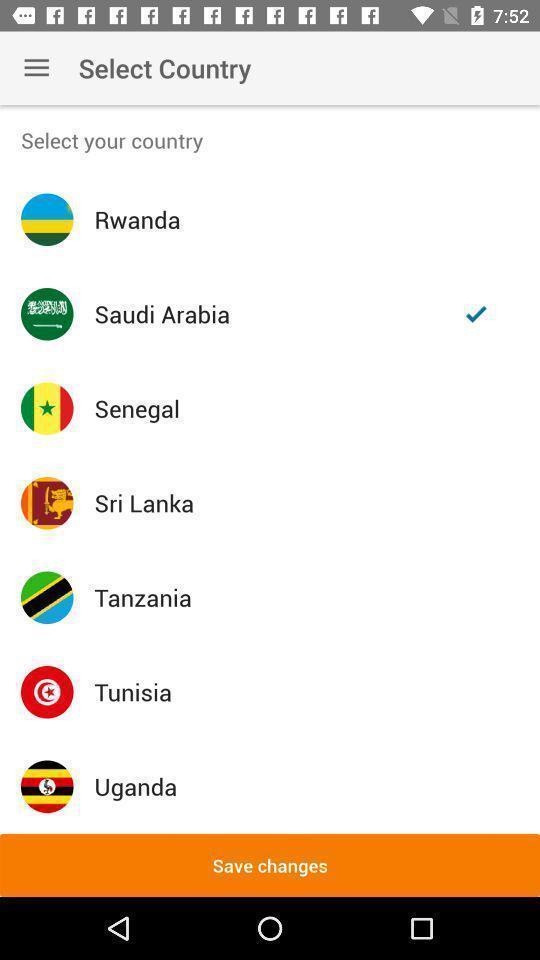Describe the visual elements of this screenshot. Page displaying list of countries to select. 